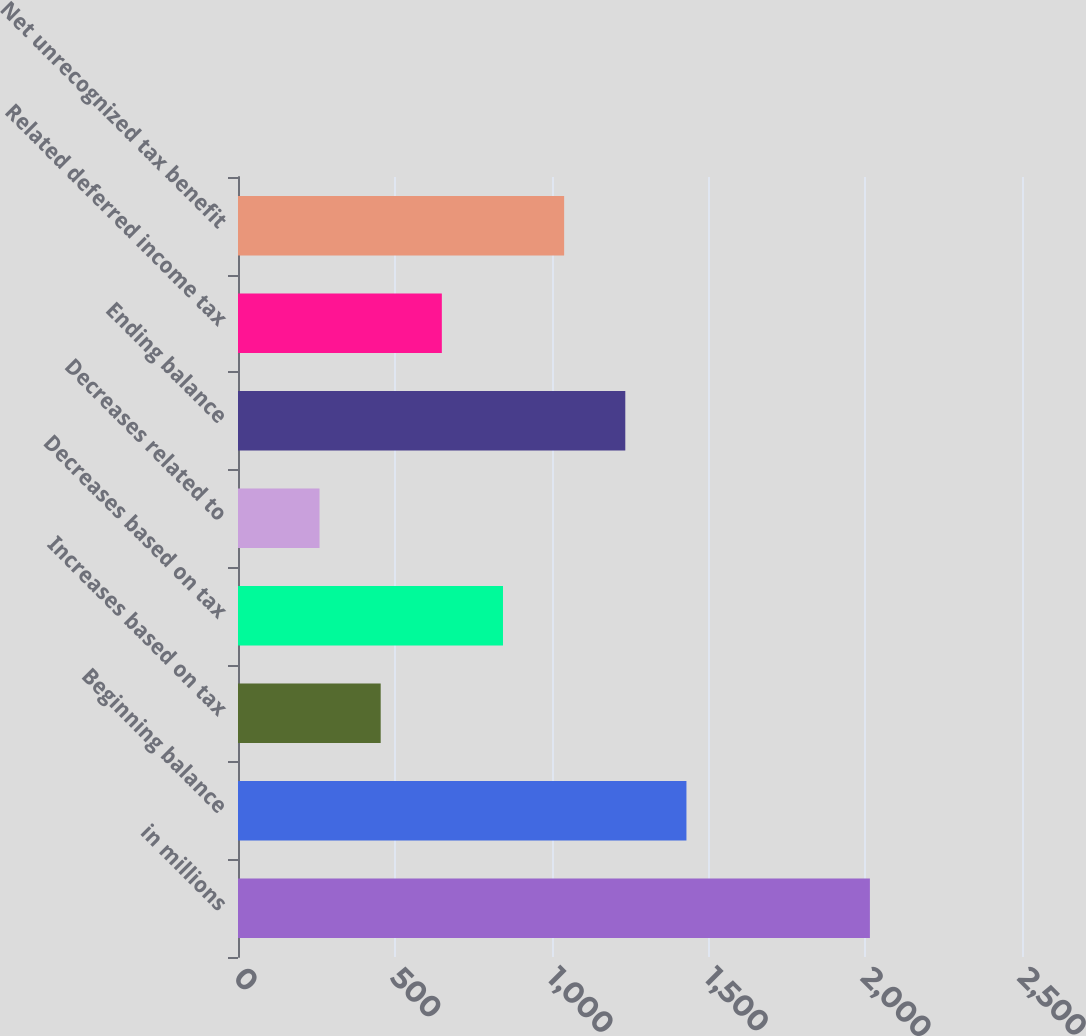Convert chart to OTSL. <chart><loc_0><loc_0><loc_500><loc_500><bar_chart><fcel>in millions<fcel>Beginning balance<fcel>Increases based on tax<fcel>Decreases based on tax<fcel>Decreases related to<fcel>Ending balance<fcel>Related deferred income tax<fcel>Net unrecognized tax benefit<nl><fcel>2015<fcel>1430<fcel>455<fcel>845<fcel>260<fcel>1235<fcel>650<fcel>1040<nl></chart> 